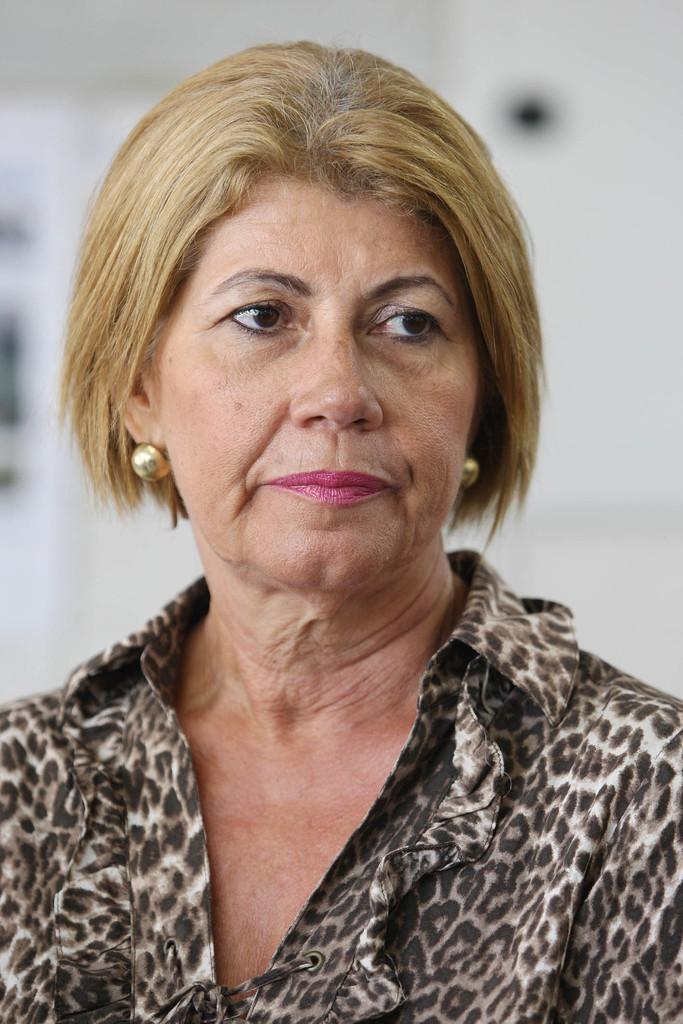Who is the main subject in the image? There is a woman in the image. What is a distinctive feature of the woman's appearance? The woman has yellow hair. What is the woman wearing in the image? The woman is wearing a white and brown dress. Can you describe the background of the image? The background of the image is blurred. What type of structure can be seen in the image? There is a wall in the image. What type of machine is the woman using to hear better in the image? There is no machine present in the image, and the woman's hearing is not mentioned or depicted. 